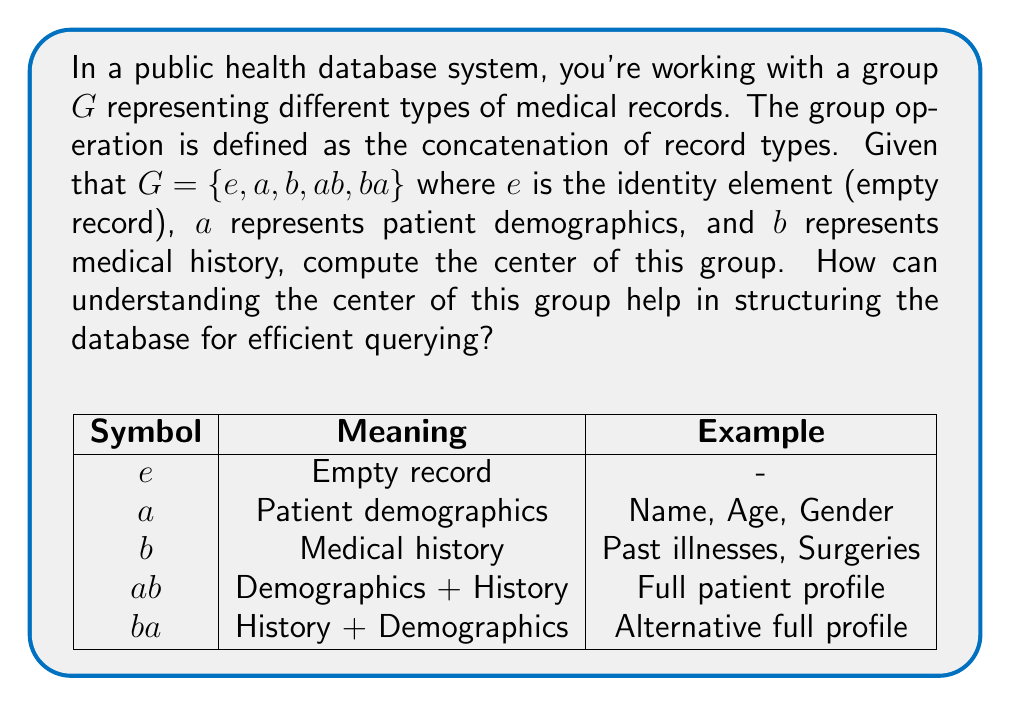Could you help me with this problem? To compute the center of the group $G$, we need to find all elements that commute with every element in the group. Let's follow these steps:

1) The center of a group $G$ is defined as:
   $$Z(G) = \{z \in G : zg = gz \text{ for all } g \in G\}$$

2) Let's check each element:

   For $e$:
   $e$ commutes with all elements (property of identity), so $e \in Z(G)$

   For $a$:
   $aa = a$, $ab \neq ba$, so $a \notin Z(G)$

   For $b$:
   $bb = b$, $ab \neq ba$, so $b \notin Z(G)$

   For $ab$:
   $ab \cdot a = aba \neq a \cdot ab = ab$, so $ab \notin Z(G)$

   For $ba$:
   $ba \cdot a = baa = ba \neq a \cdot ba = ab$, so $ba \notin Z(G)$

3) Therefore, the center of $G$ is $Z(G) = \{e\}$

Understanding the center of this group can help in structuring the database for efficient querying in the following ways:

1) The center represents elements that can be freely moved within any query or data structure without changing the result.

2) In this case, only the empty record ($e$) can be freely moved, indicating that the order of patient demographics and medical history is significant in the database structure.

3) This suggests that queries should be designed to respect the order of record types, and data should be stored in a way that preserves this order for efficient retrieval.

4) The non-commutativity of other elements implies that separate indices or access paths may be needed for different orderings of record types, potentially influencing the database schema design.
Answer: $Z(G) = \{e\}$ 